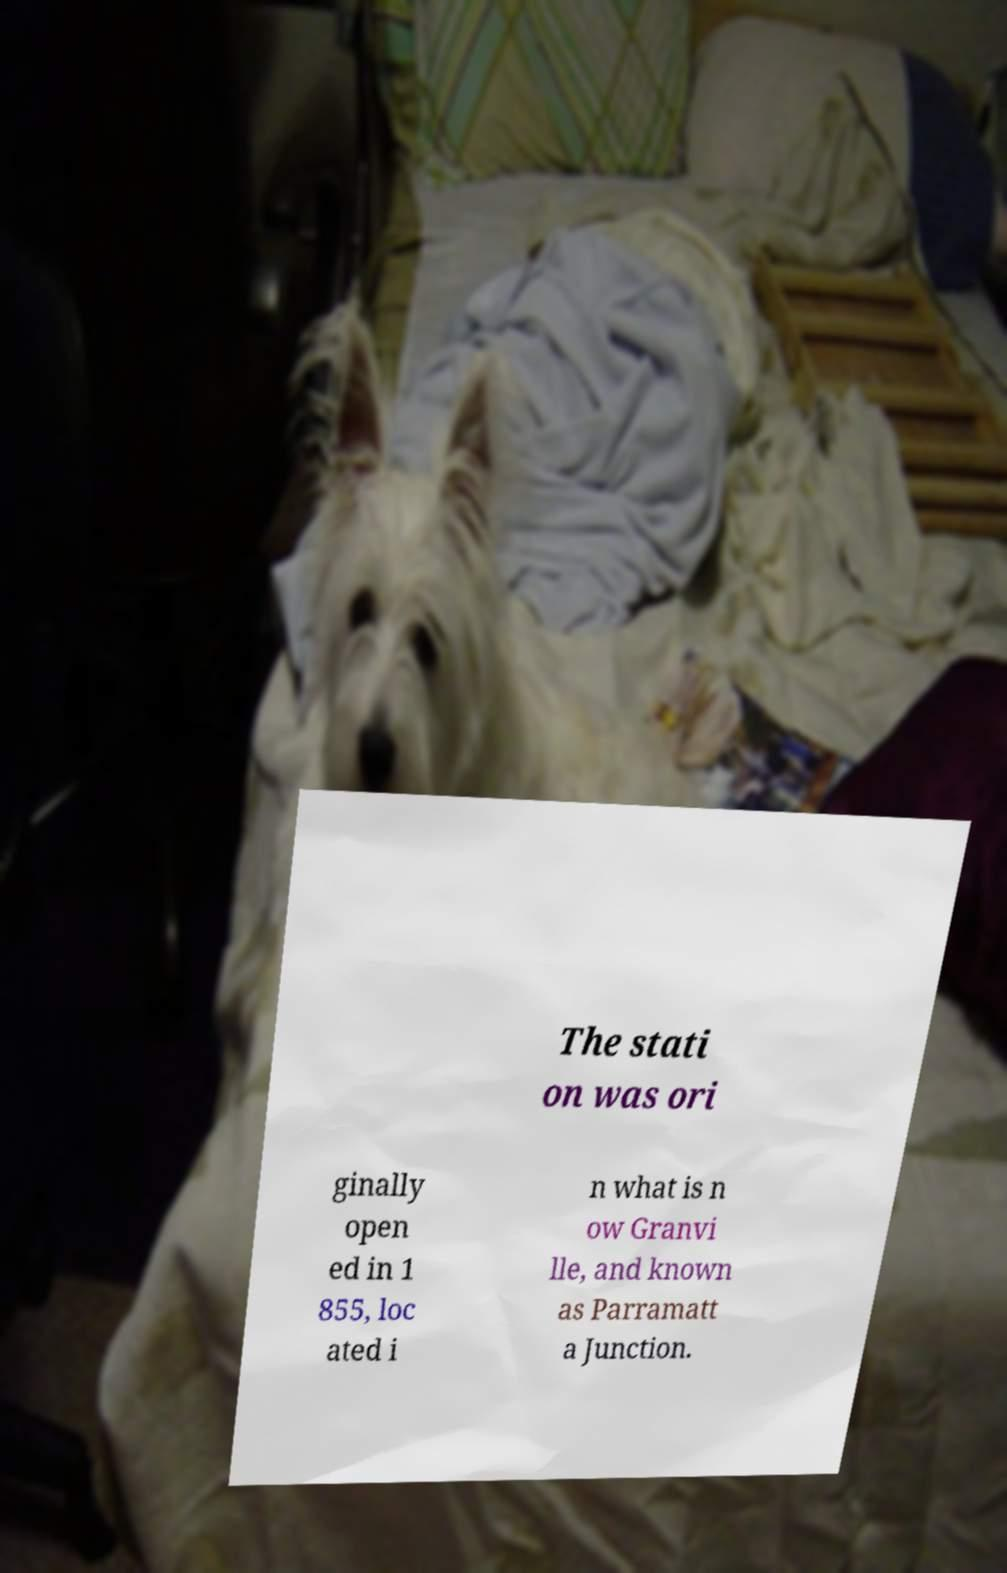For documentation purposes, I need the text within this image transcribed. Could you provide that? The stati on was ori ginally open ed in 1 855, loc ated i n what is n ow Granvi lle, and known as Parramatt a Junction. 